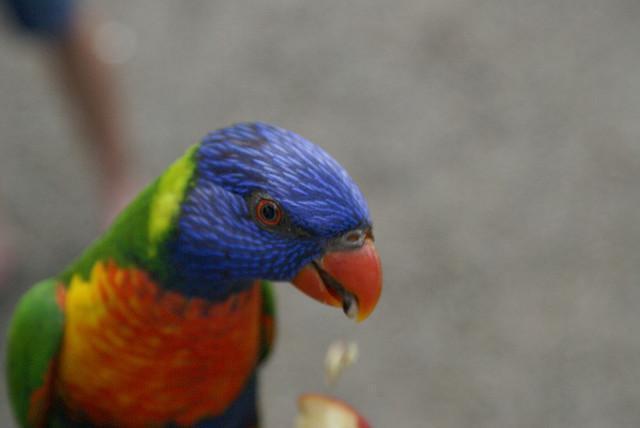How many bird are in the photo?
Give a very brief answer. 1. 